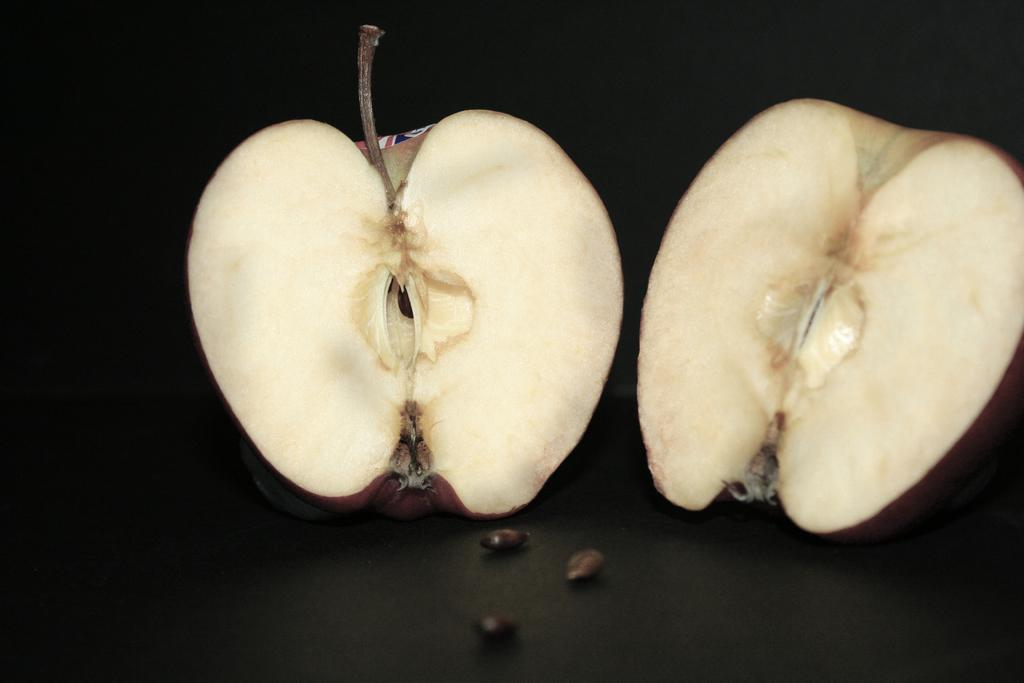What is the main subject of the image? The main subject of the image is an apple. How is the apple presented in the image? The apple is cut into two pieces in the image. What can be seen on the surface beneath the apple? There are seeds on a black color surface. What is the color of the background in the image? The background of the image is dark. What type of bird can be seen flying in the image? There is no bird present in the image; it features an apple cut into two pieces on a black surface with seeds. Can you describe the lunchroom where the apple is being served in the image? There is no lunchroom depicted in the image; it only shows an apple cut into two pieces on a black surface with seeds. 